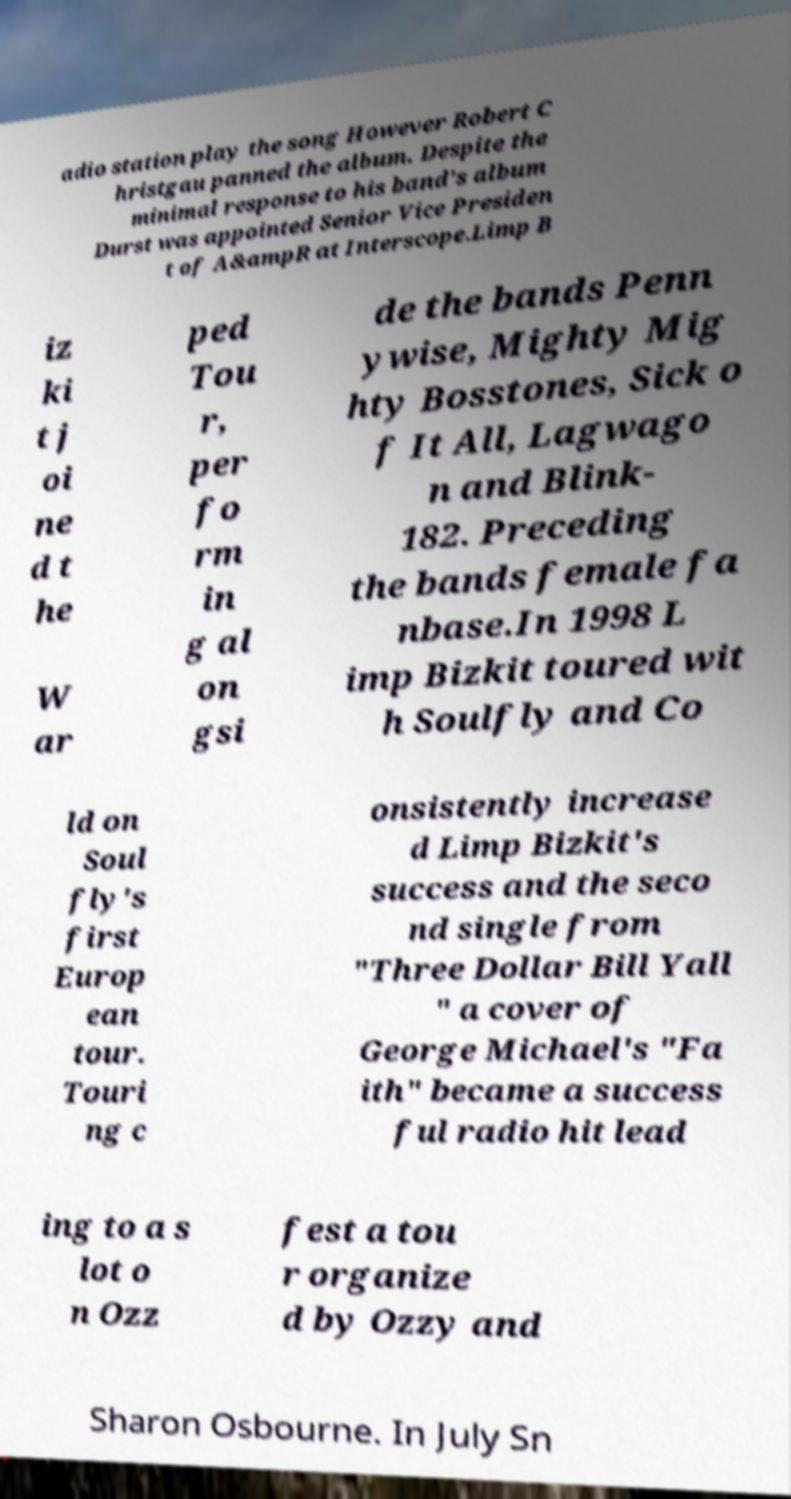I need the written content from this picture converted into text. Can you do that? adio station play the song However Robert C hristgau panned the album. Despite the minimal response to his band's album Durst was appointed Senior Vice Presiden t of A&ampR at Interscope.Limp B iz ki t j oi ne d t he W ar ped Tou r, per fo rm in g al on gsi de the bands Penn ywise, Mighty Mig hty Bosstones, Sick o f It All, Lagwago n and Blink- 182. Preceding the bands female fa nbase.In 1998 L imp Bizkit toured wit h Soulfly and Co ld on Soul fly's first Europ ean tour. Touri ng c onsistently increase d Limp Bizkit's success and the seco nd single from "Three Dollar Bill Yall " a cover of George Michael's "Fa ith" became a success ful radio hit lead ing to a s lot o n Ozz fest a tou r organize d by Ozzy and Sharon Osbourne. In July Sn 